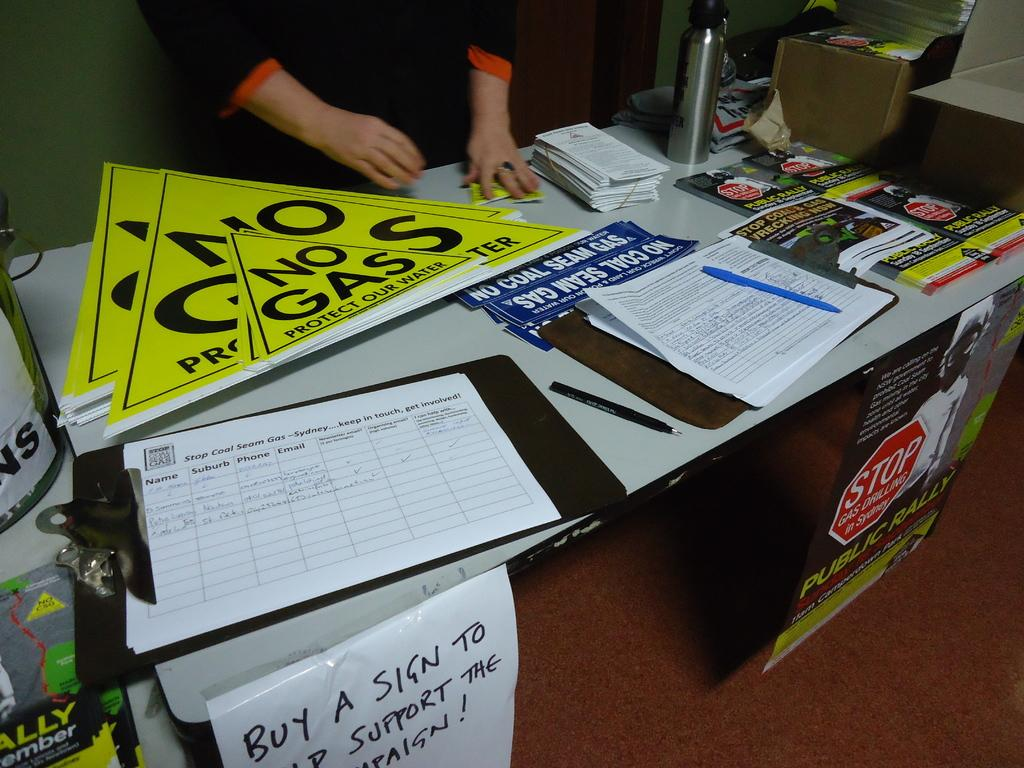<image>
Write a terse but informative summary of the picture. Yellow signs that say no gas sit on a table. 